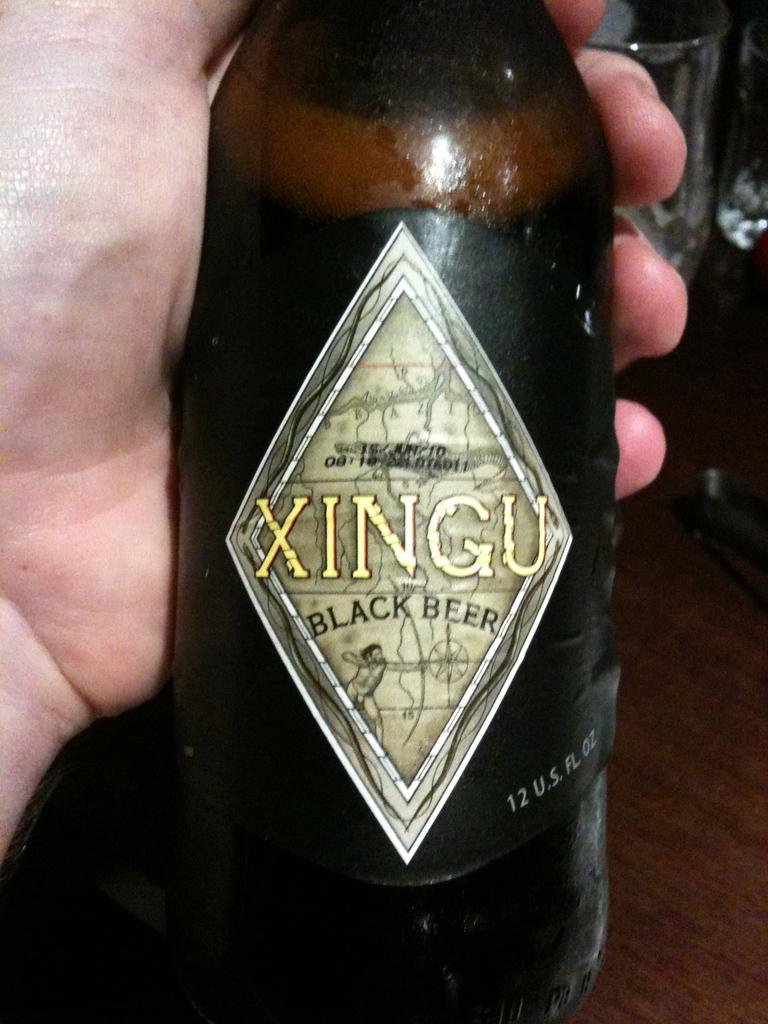What is being held by the hand in the picture? There is a black bottle in the hand. What can be seen on the black bottle? There is text written on the bottle. What objects are visible on the table in the background? There are two glasses on a table in the background. How does the hand provide comfort to the eye in the image? The hand and eye are not interacting in the image, and there is no indication of comfort being provided. 